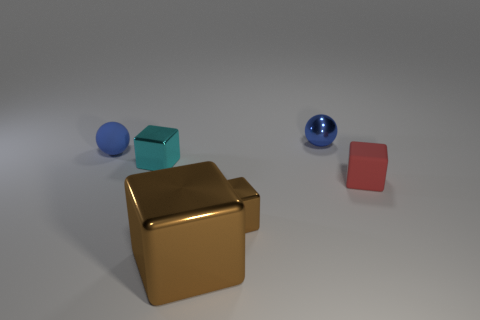What size is the cyan shiny block?
Your answer should be very brief. Small. Are there any cyan blocks that have the same material as the tiny brown thing?
Offer a very short reply. Yes. There is a red matte thing that is the same shape as the tiny cyan object; what is its size?
Keep it short and to the point. Small. Is the number of tiny brown cubes in front of the large brown metal block the same as the number of big blue shiny things?
Your response must be concise. Yes. There is a small blue thing on the right side of the small cyan metal cube; is its shape the same as the small blue rubber thing?
Offer a very short reply. Yes. The tiny brown object is what shape?
Provide a short and direct response. Cube. There is a tiny cube in front of the rubber thing in front of the blue thing that is to the left of the cyan object; what is its material?
Your answer should be compact. Metal. There is a small block that is the same color as the large shiny thing; what is it made of?
Make the answer very short. Metal. What number of things are either brown rubber things or brown metal blocks?
Your response must be concise. 2. Is the small blue sphere right of the tiny brown cube made of the same material as the tiny brown thing?
Make the answer very short. Yes. 